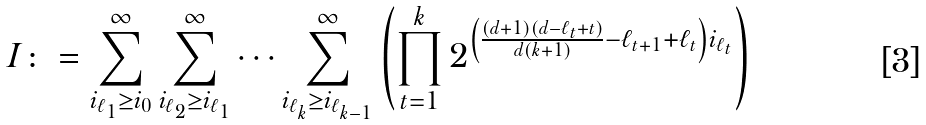Convert formula to latex. <formula><loc_0><loc_0><loc_500><loc_500>I \colon = \sum _ { i _ { \ell _ { 1 } } \geq i _ { 0 } } ^ { \infty } \sum _ { i _ { \ell _ { 2 } } \geq i _ { \ell _ { 1 } } } ^ { \infty } \cdots \sum _ { i _ { \ell _ { k } } \geq i _ { \ell _ { k - 1 } } } ^ { \infty } \left ( \prod _ { t = 1 } ^ { k } 2 ^ { \left ( \frac { ( d + 1 ) ( d - \ell _ { t } + t ) } { d ( k + 1 ) } - \ell _ { t + 1 } + \ell _ { t } \right ) i _ { \ell _ { t } } } \right )</formula> 